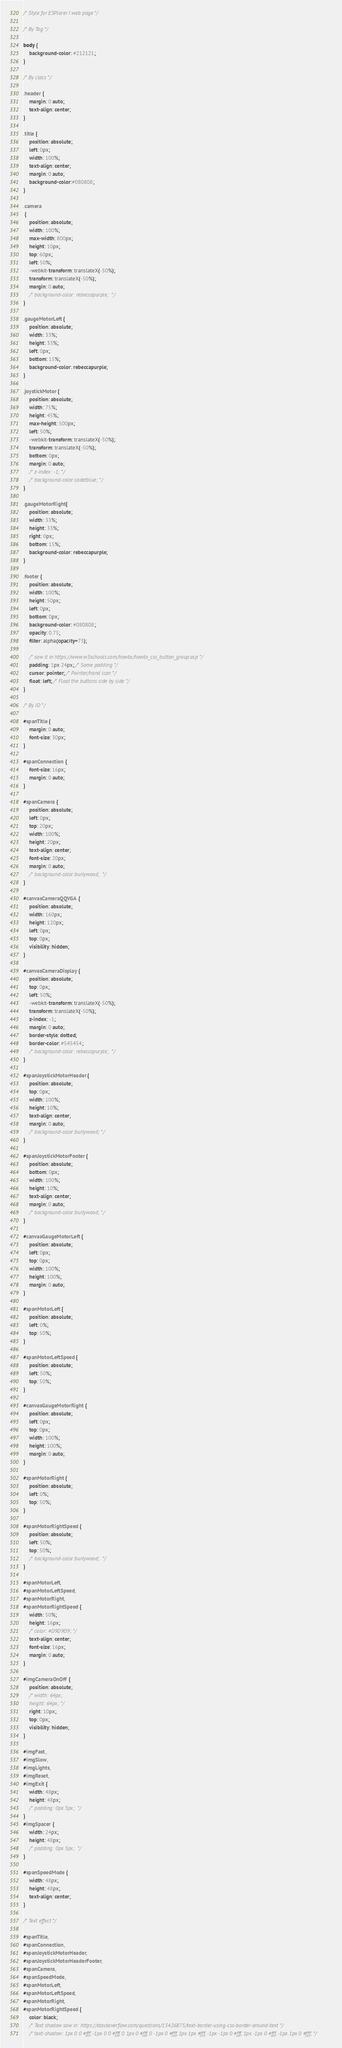Convert code to text. <code><loc_0><loc_0><loc_500><loc_500><_CSS_>/* Style for ESPlorer I web page */

/* By Tag */

body {
    background-color: #212121;
}

/* By class */

.header {
    margin: 0 auto;
    text-align: center;
}

.title {
    position: absolute;
    left: 0px;
    width: 100%;
    text-align: center;
    margin: 0 auto;
    background-color:#080808;
}

.camera
 {
    position: absolute;
    width: 100%;
    max-width: 800px; 
    height: 10px;
    top: 60px;
    left: 50%;
    -webkit-transform: translateX(-50%);
    transform: translateX(-50%);
    margin: 0 auto;
    /* background-color: rebeccapurple;  */
}

.gaugeMotorLeft {
    position: absolute;
    width: 33%;
    height: 33%;
    left: 0px;
    bottom: 15%;
    background-color: rebeccapurple;  
}

.joystickMotor {
    position: absolute;
    width: 75%;
    height: 45%;
    max-height: 500px;
    left: 50%;
    -webkit-transform: translateX(-50%);
    transform: translateX(-50%);
    bottom: 0px;
    margin: 0 auto;
    /* z-index: -1; */
    /* background-color:cadetblue; */
}

.gaugeMotorRight{
    position: absolute;
    width: 33%;
    height: 33%;
    right: 0px;
    bottom: 15%;
    background-color: rebeccapurple;
}

.footer {
    position: absolute;
    width: 100%;
    height: 50px;
    left: 0px;
    bottom: 0px;
    background-color: #080808;
    opacity: 0.75;
    filter: alpha(opacity=75); 

    /* saw it in https://www.w3schools.com/howto/howto_css_button_group.asp */
    padding: 1px 24px; /* Some padding */
    cursor: pointer; /* Pointer/hand icon */
    float: left; /* Float the buttons side by side */
}

/* By ID */

#spanTitle {
    margin: 0 auto;
    font-size: 30px;
}

#spanConnection {
    font-size: 16px;
    margin: 0 auto;
}

#spanCamera {
    position: absolute;
    left: 0px;
    top: 20px;
    width: 100%;
    height: 20px;
    text-align: center;
    font-size: 20px;
    margin: 0 auto;
    /* background-color:burlywood;  */
}

#canvasCameraQQVGA {
    position: absolute;
    width: 160px;
    height: 120px;
    left: 0px;
    top: 0px;
    visibility: hidden;
}

#canvasCameraDisplay {
    position: absolute;
    top: 0px;
    left: 50%;
    -webkit-transform: translateX(-50%);
    transform: translateX(-50%);
    z-index: -1;
    margin: 0 auto;
    border-style: dotted;
    border-color: #545454; 
    /* background-color: rebeccapurple;  */
}

#spanJoystickMotorHeader {
    position: absolute;
    top: 0px;
    width: 100%;
    height: 10%;
    text-align: center;
    margin: 0 auto;
    /* background-color:burlywood; */
}

#spanJoystickMotorFooter {
    position: absolute;
    bottom: 0px;
    width: 100%;
    height: 10%;
    text-align: center;
    margin: 0 auto;
    /* background-color:burlywood; */
}

#canvasGaugeMotorLeft {
    position: absolute;
    left: 0px;
    top: 0px;
    width: 100%;
    height: 100%;
    margin: 0 auto;
}

#spanMotorLeft {
    position: absolute;
    left: 0%;
    top: 50%;
}

#spanMotorLeftSpeed {
    position: absolute;
    left: 50%;
    top: 50%;
}

#canvasGaugeMotorRight {
    position: absolute;
    left: 0px;
    top: 0px;
    width: 100%;
    height: 100%;
    margin: 0 auto;
}

#spanMotorRight {
    position: absolute;
    left: 0%;
    top: 50%;
}

#spanMotorRightSpeed {
    position: absolute;
    left: 50%;
    top: 50%;
    /* background-color:burlywood;  */
}

#spanMotorLeft,
#spanMotorLeftSpeed,
#spanMotorRight,
#spanMotorRightSpeed {
    width: 50%;
    height: 16px;
    /* color: #D9D9D9; */
    text-align: center;
    font-size: 16px;
    margin: 0 auto;
}

#imgCameraOnOff {
    position: absolute;
    /* width: 64px;
    height: 64px; */
    right: 10px;
    top: 0px;
    visibility: hidden;
}

#imgFast,
#imgSlow,
#imgLights,
#imgReset,
#imgExit {
    width: 48px;
    height: 48px;
    /* padding: 0px 5px;  */
}
#imgSpacer {
    width: 24px;
    height: 48px;
    /* padding: 0px 5px;  */
}

#spanSpeedMode {
    width: 48px;
    height: 48px;
    text-align: center;
}

/* Text effect */

#spanTitle,
#spanConnection,
#spanJoystickMotorHeader,
#spanJoystickMotorHeaderFooter,
#spanCamera,
#spanSpeedMode,
#spanMotorLeft,
#spanMotorLeftSpeed,
#spanMotorRight,
#spanMotorRightSpeed {    
    color: black;
    /* Text shadow saw in: https://stackoverflow.com/questions/13426875/text-border-using-css-border-around-text */
    /* text-shadow: 1px 0 0 #fff, -1px 0 0 #fff, 0 1px 0 #fff, 0 -1px 0 #fff, 1px 1px #fff, -1px -1px 0 #fff, 1px -1px 0 #fff, -1px 1px 0 #fff; */</code> 